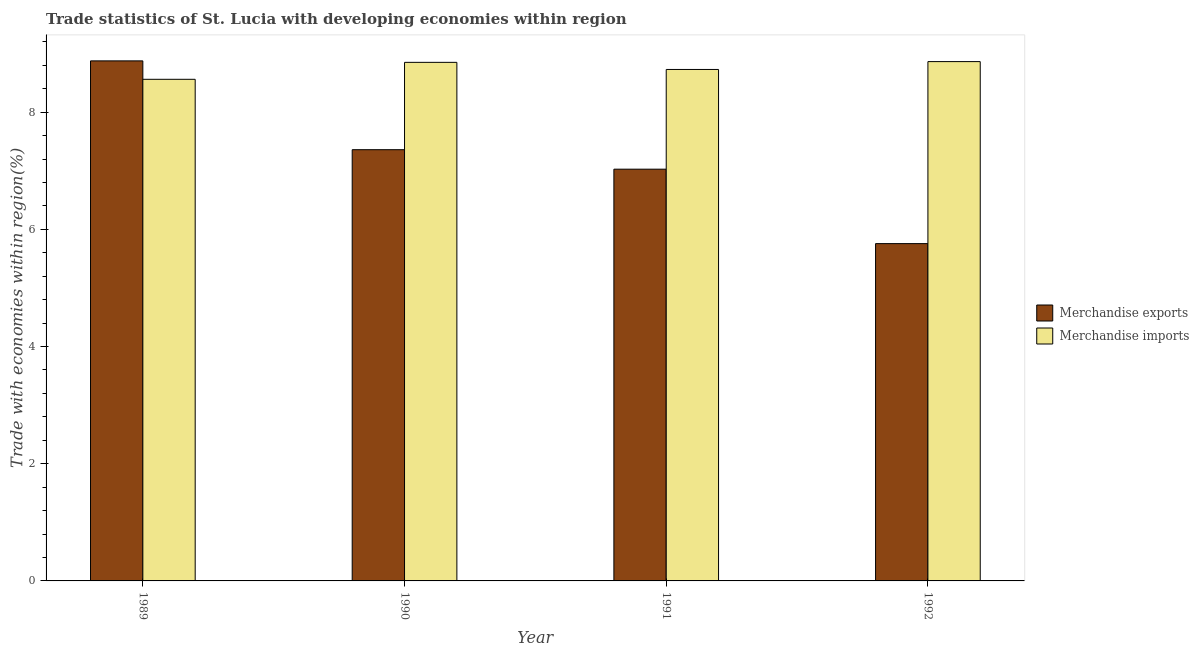How many different coloured bars are there?
Make the answer very short. 2. How many groups of bars are there?
Ensure brevity in your answer.  4. How many bars are there on the 2nd tick from the right?
Your answer should be very brief. 2. What is the label of the 2nd group of bars from the left?
Make the answer very short. 1990. What is the merchandise imports in 1990?
Keep it short and to the point. 8.85. Across all years, what is the maximum merchandise exports?
Your response must be concise. 8.88. Across all years, what is the minimum merchandise exports?
Keep it short and to the point. 5.76. In which year was the merchandise imports maximum?
Your answer should be compact. 1992. What is the total merchandise imports in the graph?
Give a very brief answer. 35. What is the difference between the merchandise exports in 1990 and that in 1992?
Your answer should be compact. 1.6. What is the difference between the merchandise exports in 1992 and the merchandise imports in 1991?
Your answer should be very brief. -1.27. What is the average merchandise imports per year?
Your response must be concise. 8.75. In the year 1991, what is the difference between the merchandise exports and merchandise imports?
Provide a short and direct response. 0. What is the ratio of the merchandise exports in 1990 to that in 1992?
Your answer should be compact. 1.28. Is the difference between the merchandise imports in 1990 and 1992 greater than the difference between the merchandise exports in 1990 and 1992?
Provide a succinct answer. No. What is the difference between the highest and the second highest merchandise exports?
Make the answer very short. 1.52. What is the difference between the highest and the lowest merchandise imports?
Give a very brief answer. 0.3. Is the sum of the merchandise exports in 1990 and 1992 greater than the maximum merchandise imports across all years?
Offer a terse response. Yes. What does the 2nd bar from the right in 1990 represents?
Your answer should be very brief. Merchandise exports. Are all the bars in the graph horizontal?
Make the answer very short. No. Does the graph contain any zero values?
Offer a very short reply. No. Where does the legend appear in the graph?
Provide a succinct answer. Center right. How many legend labels are there?
Make the answer very short. 2. What is the title of the graph?
Give a very brief answer. Trade statistics of St. Lucia with developing economies within region. Does "Time to import" appear as one of the legend labels in the graph?
Your response must be concise. No. What is the label or title of the X-axis?
Offer a very short reply. Year. What is the label or title of the Y-axis?
Ensure brevity in your answer.  Trade with economies within region(%). What is the Trade with economies within region(%) of Merchandise exports in 1989?
Provide a short and direct response. 8.88. What is the Trade with economies within region(%) of Merchandise imports in 1989?
Make the answer very short. 8.56. What is the Trade with economies within region(%) in Merchandise exports in 1990?
Ensure brevity in your answer.  7.36. What is the Trade with economies within region(%) of Merchandise imports in 1990?
Give a very brief answer. 8.85. What is the Trade with economies within region(%) of Merchandise exports in 1991?
Offer a very short reply. 7.03. What is the Trade with economies within region(%) in Merchandise imports in 1991?
Your response must be concise. 8.73. What is the Trade with economies within region(%) in Merchandise exports in 1992?
Your answer should be very brief. 5.76. What is the Trade with economies within region(%) of Merchandise imports in 1992?
Provide a short and direct response. 8.86. Across all years, what is the maximum Trade with economies within region(%) in Merchandise exports?
Make the answer very short. 8.88. Across all years, what is the maximum Trade with economies within region(%) of Merchandise imports?
Your answer should be very brief. 8.86. Across all years, what is the minimum Trade with economies within region(%) in Merchandise exports?
Provide a short and direct response. 5.76. Across all years, what is the minimum Trade with economies within region(%) in Merchandise imports?
Offer a terse response. 8.56. What is the total Trade with economies within region(%) in Merchandise exports in the graph?
Keep it short and to the point. 29.02. What is the total Trade with economies within region(%) in Merchandise imports in the graph?
Ensure brevity in your answer.  35. What is the difference between the Trade with economies within region(%) of Merchandise exports in 1989 and that in 1990?
Ensure brevity in your answer.  1.52. What is the difference between the Trade with economies within region(%) in Merchandise imports in 1989 and that in 1990?
Offer a terse response. -0.29. What is the difference between the Trade with economies within region(%) of Merchandise exports in 1989 and that in 1991?
Offer a terse response. 1.85. What is the difference between the Trade with economies within region(%) of Merchandise imports in 1989 and that in 1991?
Offer a very short reply. -0.17. What is the difference between the Trade with economies within region(%) in Merchandise exports in 1989 and that in 1992?
Ensure brevity in your answer.  3.12. What is the difference between the Trade with economies within region(%) of Merchandise imports in 1989 and that in 1992?
Your answer should be compact. -0.3. What is the difference between the Trade with economies within region(%) in Merchandise exports in 1990 and that in 1991?
Your answer should be very brief. 0.33. What is the difference between the Trade with economies within region(%) in Merchandise imports in 1990 and that in 1991?
Make the answer very short. 0.12. What is the difference between the Trade with economies within region(%) of Merchandise exports in 1990 and that in 1992?
Provide a succinct answer. 1.6. What is the difference between the Trade with economies within region(%) of Merchandise imports in 1990 and that in 1992?
Provide a succinct answer. -0.01. What is the difference between the Trade with economies within region(%) in Merchandise exports in 1991 and that in 1992?
Make the answer very short. 1.27. What is the difference between the Trade with economies within region(%) in Merchandise imports in 1991 and that in 1992?
Your response must be concise. -0.13. What is the difference between the Trade with economies within region(%) in Merchandise exports in 1989 and the Trade with economies within region(%) in Merchandise imports in 1990?
Keep it short and to the point. 0.03. What is the difference between the Trade with economies within region(%) in Merchandise exports in 1989 and the Trade with economies within region(%) in Merchandise imports in 1991?
Make the answer very short. 0.15. What is the difference between the Trade with economies within region(%) of Merchandise exports in 1989 and the Trade with economies within region(%) of Merchandise imports in 1992?
Your answer should be compact. 0.01. What is the difference between the Trade with economies within region(%) of Merchandise exports in 1990 and the Trade with economies within region(%) of Merchandise imports in 1991?
Provide a short and direct response. -1.37. What is the difference between the Trade with economies within region(%) of Merchandise exports in 1990 and the Trade with economies within region(%) of Merchandise imports in 1992?
Your response must be concise. -1.5. What is the difference between the Trade with economies within region(%) of Merchandise exports in 1991 and the Trade with economies within region(%) of Merchandise imports in 1992?
Your answer should be very brief. -1.84. What is the average Trade with economies within region(%) in Merchandise exports per year?
Your response must be concise. 7.25. What is the average Trade with economies within region(%) in Merchandise imports per year?
Give a very brief answer. 8.75. In the year 1989, what is the difference between the Trade with economies within region(%) of Merchandise exports and Trade with economies within region(%) of Merchandise imports?
Make the answer very short. 0.31. In the year 1990, what is the difference between the Trade with economies within region(%) of Merchandise exports and Trade with economies within region(%) of Merchandise imports?
Ensure brevity in your answer.  -1.49. In the year 1991, what is the difference between the Trade with economies within region(%) in Merchandise exports and Trade with economies within region(%) in Merchandise imports?
Make the answer very short. -1.7. In the year 1992, what is the difference between the Trade with economies within region(%) in Merchandise exports and Trade with economies within region(%) in Merchandise imports?
Offer a terse response. -3.11. What is the ratio of the Trade with economies within region(%) of Merchandise exports in 1989 to that in 1990?
Keep it short and to the point. 1.21. What is the ratio of the Trade with economies within region(%) in Merchandise imports in 1989 to that in 1990?
Your response must be concise. 0.97. What is the ratio of the Trade with economies within region(%) of Merchandise exports in 1989 to that in 1991?
Ensure brevity in your answer.  1.26. What is the ratio of the Trade with economies within region(%) in Merchandise imports in 1989 to that in 1991?
Make the answer very short. 0.98. What is the ratio of the Trade with economies within region(%) of Merchandise exports in 1989 to that in 1992?
Provide a short and direct response. 1.54. What is the ratio of the Trade with economies within region(%) in Merchandise imports in 1989 to that in 1992?
Offer a terse response. 0.97. What is the ratio of the Trade with economies within region(%) of Merchandise exports in 1990 to that in 1991?
Offer a very short reply. 1.05. What is the ratio of the Trade with economies within region(%) in Merchandise imports in 1990 to that in 1991?
Give a very brief answer. 1.01. What is the ratio of the Trade with economies within region(%) of Merchandise exports in 1990 to that in 1992?
Offer a terse response. 1.28. What is the ratio of the Trade with economies within region(%) of Merchandise exports in 1991 to that in 1992?
Make the answer very short. 1.22. What is the ratio of the Trade with economies within region(%) of Merchandise imports in 1991 to that in 1992?
Your answer should be very brief. 0.98. What is the difference between the highest and the second highest Trade with economies within region(%) in Merchandise exports?
Make the answer very short. 1.52. What is the difference between the highest and the second highest Trade with economies within region(%) of Merchandise imports?
Your answer should be compact. 0.01. What is the difference between the highest and the lowest Trade with economies within region(%) of Merchandise exports?
Give a very brief answer. 3.12. What is the difference between the highest and the lowest Trade with economies within region(%) in Merchandise imports?
Give a very brief answer. 0.3. 